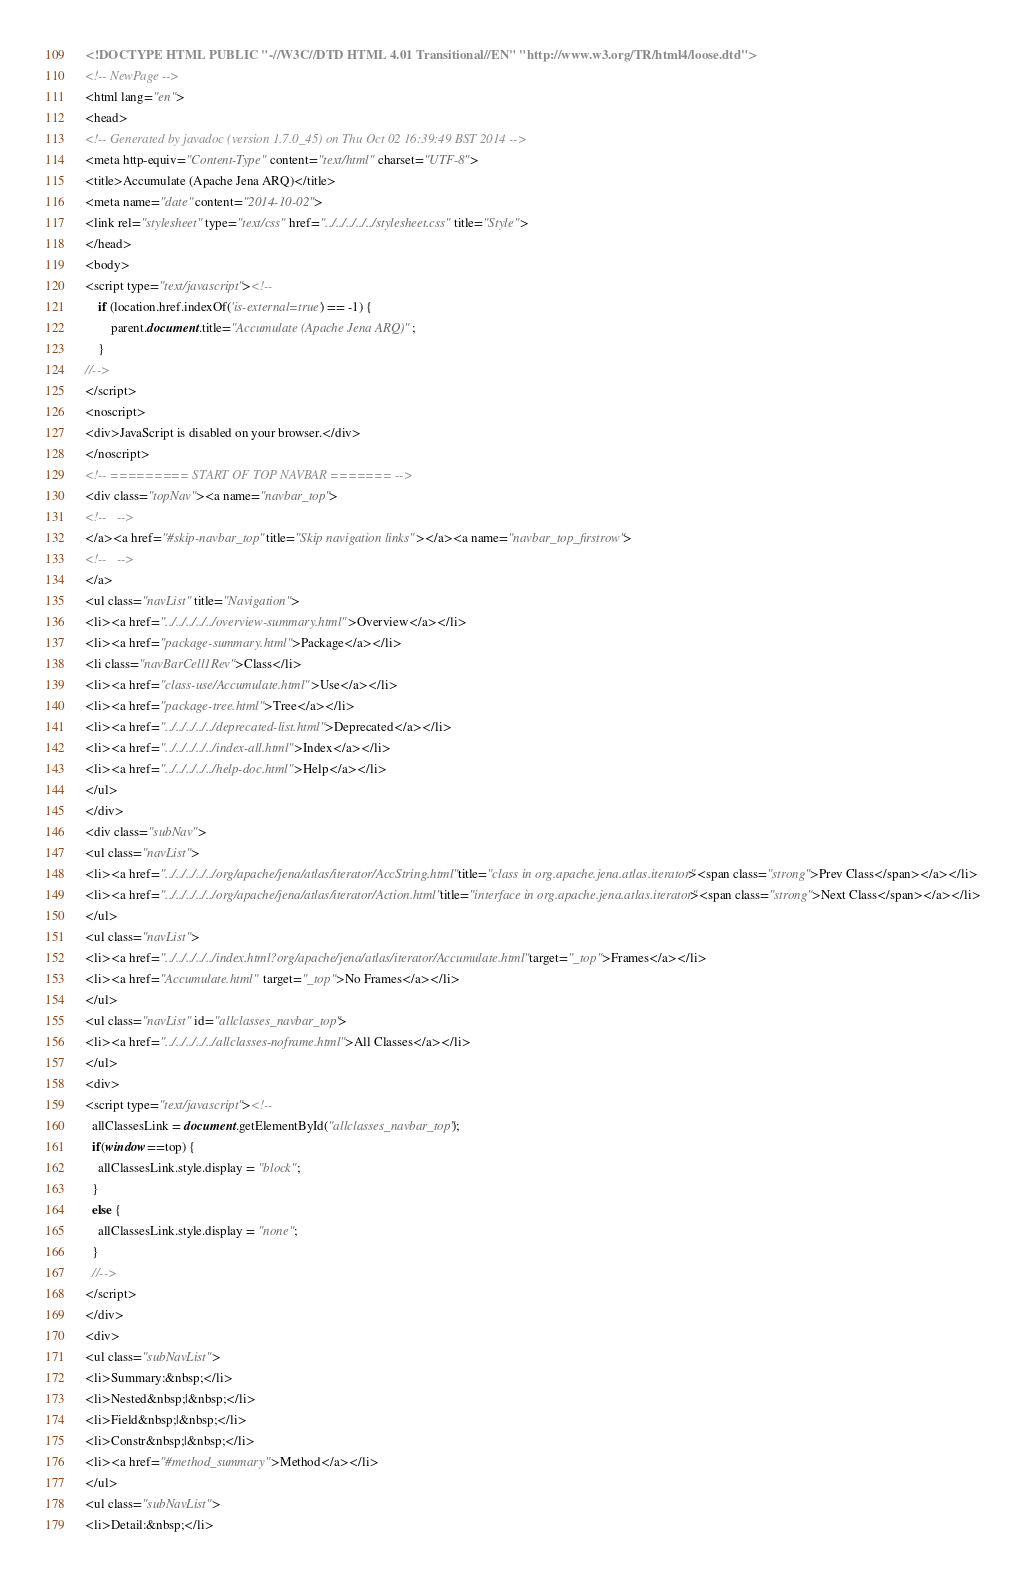<code> <loc_0><loc_0><loc_500><loc_500><_HTML_><!DOCTYPE HTML PUBLIC "-//W3C//DTD HTML 4.01 Transitional//EN" "http://www.w3.org/TR/html4/loose.dtd">
<!-- NewPage -->
<html lang="en">
<head>
<!-- Generated by javadoc (version 1.7.0_45) on Thu Oct 02 16:39:49 BST 2014 -->
<meta http-equiv="Content-Type" content="text/html" charset="UTF-8">
<title>Accumulate (Apache Jena ARQ)</title>
<meta name="date" content="2014-10-02">
<link rel="stylesheet" type="text/css" href="../../../../../stylesheet.css" title="Style">
</head>
<body>
<script type="text/javascript"><!--
    if (location.href.indexOf('is-external=true') == -1) {
        parent.document.title="Accumulate (Apache Jena ARQ)";
    }
//-->
</script>
<noscript>
<div>JavaScript is disabled on your browser.</div>
</noscript>
<!-- ========= START OF TOP NAVBAR ======= -->
<div class="topNav"><a name="navbar_top">
<!--   -->
</a><a href="#skip-navbar_top" title="Skip navigation links"></a><a name="navbar_top_firstrow">
<!--   -->
</a>
<ul class="navList" title="Navigation">
<li><a href="../../../../../overview-summary.html">Overview</a></li>
<li><a href="package-summary.html">Package</a></li>
<li class="navBarCell1Rev">Class</li>
<li><a href="class-use/Accumulate.html">Use</a></li>
<li><a href="package-tree.html">Tree</a></li>
<li><a href="../../../../../deprecated-list.html">Deprecated</a></li>
<li><a href="../../../../../index-all.html">Index</a></li>
<li><a href="../../../../../help-doc.html">Help</a></li>
</ul>
</div>
<div class="subNav">
<ul class="navList">
<li><a href="../../../../../org/apache/jena/atlas/iterator/AccString.html" title="class in org.apache.jena.atlas.iterator"><span class="strong">Prev Class</span></a></li>
<li><a href="../../../../../org/apache/jena/atlas/iterator/Action.html" title="interface in org.apache.jena.atlas.iterator"><span class="strong">Next Class</span></a></li>
</ul>
<ul class="navList">
<li><a href="../../../../../index.html?org/apache/jena/atlas/iterator/Accumulate.html" target="_top">Frames</a></li>
<li><a href="Accumulate.html" target="_top">No Frames</a></li>
</ul>
<ul class="navList" id="allclasses_navbar_top">
<li><a href="../../../../../allclasses-noframe.html">All Classes</a></li>
</ul>
<div>
<script type="text/javascript"><!--
  allClassesLink = document.getElementById("allclasses_navbar_top");
  if(window==top) {
    allClassesLink.style.display = "block";
  }
  else {
    allClassesLink.style.display = "none";
  }
  //-->
</script>
</div>
<div>
<ul class="subNavList">
<li>Summary:&nbsp;</li>
<li>Nested&nbsp;|&nbsp;</li>
<li>Field&nbsp;|&nbsp;</li>
<li>Constr&nbsp;|&nbsp;</li>
<li><a href="#method_summary">Method</a></li>
</ul>
<ul class="subNavList">
<li>Detail:&nbsp;</li></code> 